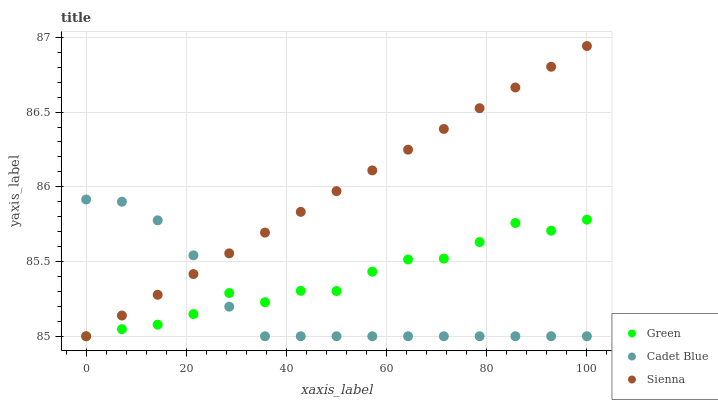Does Cadet Blue have the minimum area under the curve?
Answer yes or no. Yes. Does Sienna have the maximum area under the curve?
Answer yes or no. Yes. Does Green have the minimum area under the curve?
Answer yes or no. No. Does Green have the maximum area under the curve?
Answer yes or no. No. Is Sienna the smoothest?
Answer yes or no. Yes. Is Green the roughest?
Answer yes or no. Yes. Is Cadet Blue the smoothest?
Answer yes or no. No. Is Cadet Blue the roughest?
Answer yes or no. No. Does Sienna have the lowest value?
Answer yes or no. Yes. Does Sienna have the highest value?
Answer yes or no. Yes. Does Cadet Blue have the highest value?
Answer yes or no. No. Does Green intersect Cadet Blue?
Answer yes or no. Yes. Is Green less than Cadet Blue?
Answer yes or no. No. Is Green greater than Cadet Blue?
Answer yes or no. No. 